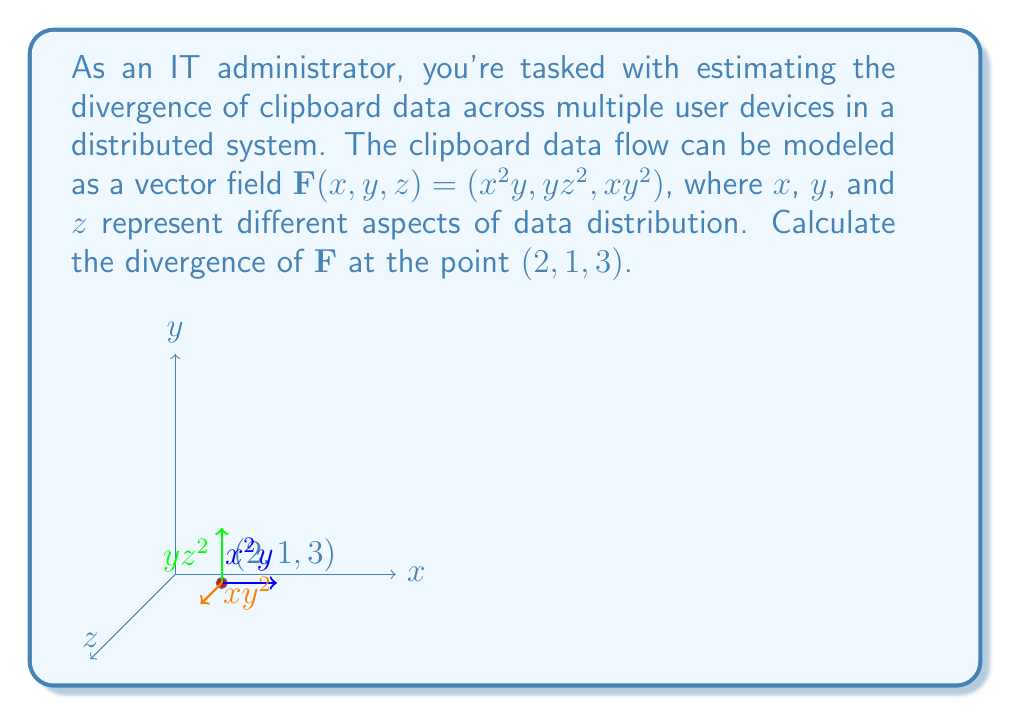Can you answer this question? To solve this problem, we need to follow these steps:

1) The divergence of a vector field $\mathbf{F}(x,y,z) = (F_1, F_2, F_3)$ is given by:

   $$\text{div}\mathbf{F} = \nabla \cdot \mathbf{F} = \frac{\partial F_1}{\partial x} + \frac{\partial F_2}{\partial y} + \frac{\partial F_3}{\partial z}$$

2) For our vector field $\mathbf{F}(x,y,z) = (x^2y, yz^2, xy^2)$, we have:
   $F_1 = x^2y$
   $F_2 = yz^2$
   $F_3 = xy^2$

3) Now, let's calculate the partial derivatives:

   $\frac{\partial F_1}{\partial x} = 2xy$
   
   $\frac{\partial F_2}{\partial y} = z^2$
   
   $\frac{\partial F_3}{\partial z} = 0$

4) The divergence is the sum of these partial derivatives:

   $$\text{div}\mathbf{F} = 2xy + z^2 + 0 = 2xy + z^2$$

5) We need to evaluate this at the point $(2,1,3)$:

   $$\text{div}\mathbf{F}(2,1,3) = 2(2)(1) + 3^2 = 4 + 9 = 13$$

Therefore, the divergence of the clipboard data flow at the point (2,1,3) is 13.
Answer: 13 